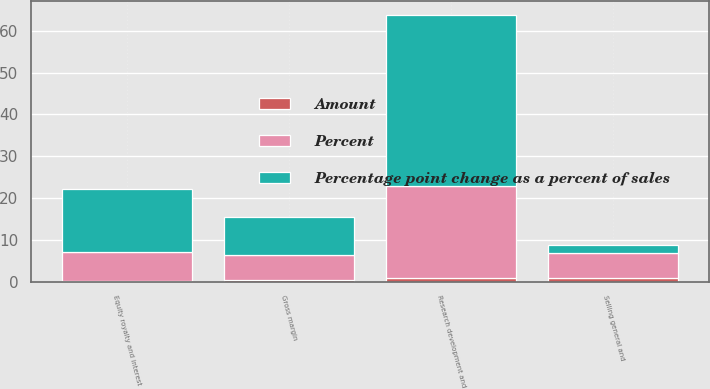Convert chart. <chart><loc_0><loc_0><loc_500><loc_500><stacked_bar_chart><ecel><fcel>Gross margin<fcel>Selling general and<fcel>Research development and<fcel>Equity royalty and interest<nl><fcel>Percent<fcel>6<fcel>6<fcel>22<fcel>7<nl><fcel>Percentage point change as a percent of sales<fcel>9<fcel>2<fcel>41<fcel>15<nl><fcel>Amount<fcel>0.4<fcel>0.8<fcel>0.8<fcel>0.1<nl></chart> 